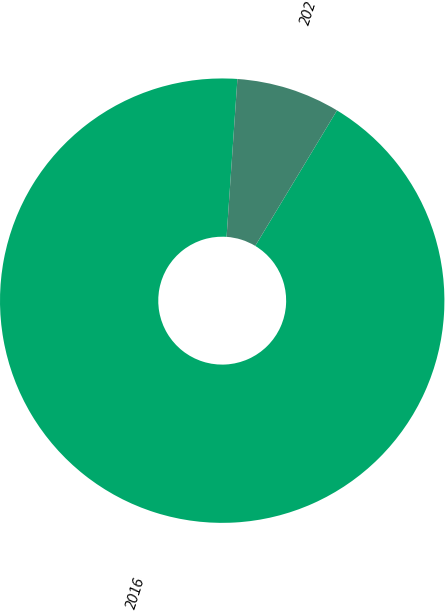Convert chart to OTSL. <chart><loc_0><loc_0><loc_500><loc_500><pie_chart><fcel>2016<fcel>202<nl><fcel>92.45%<fcel>7.55%<nl></chart> 